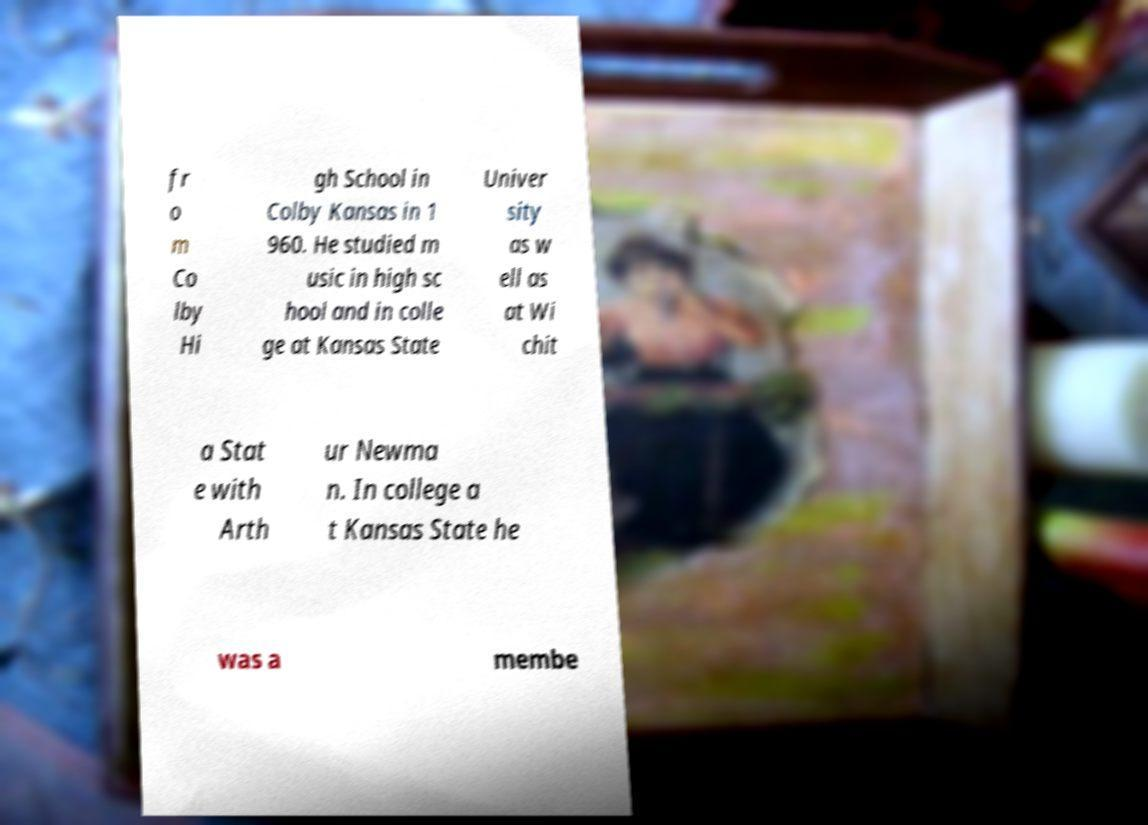For documentation purposes, I need the text within this image transcribed. Could you provide that? fr o m Co lby Hi gh School in Colby Kansas in 1 960. He studied m usic in high sc hool and in colle ge at Kansas State Univer sity as w ell as at Wi chit a Stat e with Arth ur Newma n. In college a t Kansas State he was a membe 